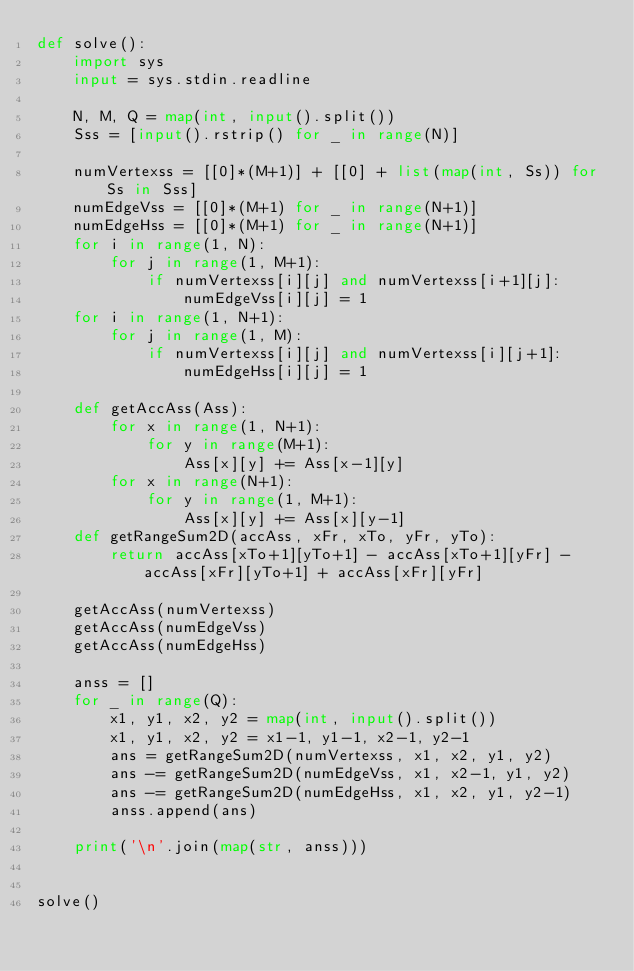<code> <loc_0><loc_0><loc_500><loc_500><_Python_>def solve():
    import sys
    input = sys.stdin.readline

    N, M, Q = map(int, input().split())
    Sss = [input().rstrip() for _ in range(N)]

    numVertexss = [[0]*(M+1)] + [[0] + list(map(int, Ss)) for Ss in Sss]
    numEdgeVss = [[0]*(M+1) for _ in range(N+1)]
    numEdgeHss = [[0]*(M+1) for _ in range(N+1)]
    for i in range(1, N):
        for j in range(1, M+1):
            if numVertexss[i][j] and numVertexss[i+1][j]:
                numEdgeVss[i][j] = 1
    for i in range(1, N+1):
        for j in range(1, M):
            if numVertexss[i][j] and numVertexss[i][j+1]:
                numEdgeHss[i][j] = 1

    def getAccAss(Ass):
        for x in range(1, N+1):
            for y in range(M+1):
                Ass[x][y] += Ass[x-1][y]
        for x in range(N+1):
            for y in range(1, M+1):
                Ass[x][y] += Ass[x][y-1]
    def getRangeSum2D(accAss, xFr, xTo, yFr, yTo):
        return accAss[xTo+1][yTo+1] - accAss[xTo+1][yFr] - accAss[xFr][yTo+1] + accAss[xFr][yFr]

    getAccAss(numVertexss)
    getAccAss(numEdgeVss)
    getAccAss(numEdgeHss)

    anss = []
    for _ in range(Q):
        x1, y1, x2, y2 = map(int, input().split())
        x1, y1, x2, y2 = x1-1, y1-1, x2-1, y2-1
        ans = getRangeSum2D(numVertexss, x1, x2, y1, y2)
        ans -= getRangeSum2D(numEdgeVss, x1, x2-1, y1, y2)
        ans -= getRangeSum2D(numEdgeHss, x1, x2, y1, y2-1)
        anss.append(ans)

    print('\n'.join(map(str, anss)))


solve()
</code> 